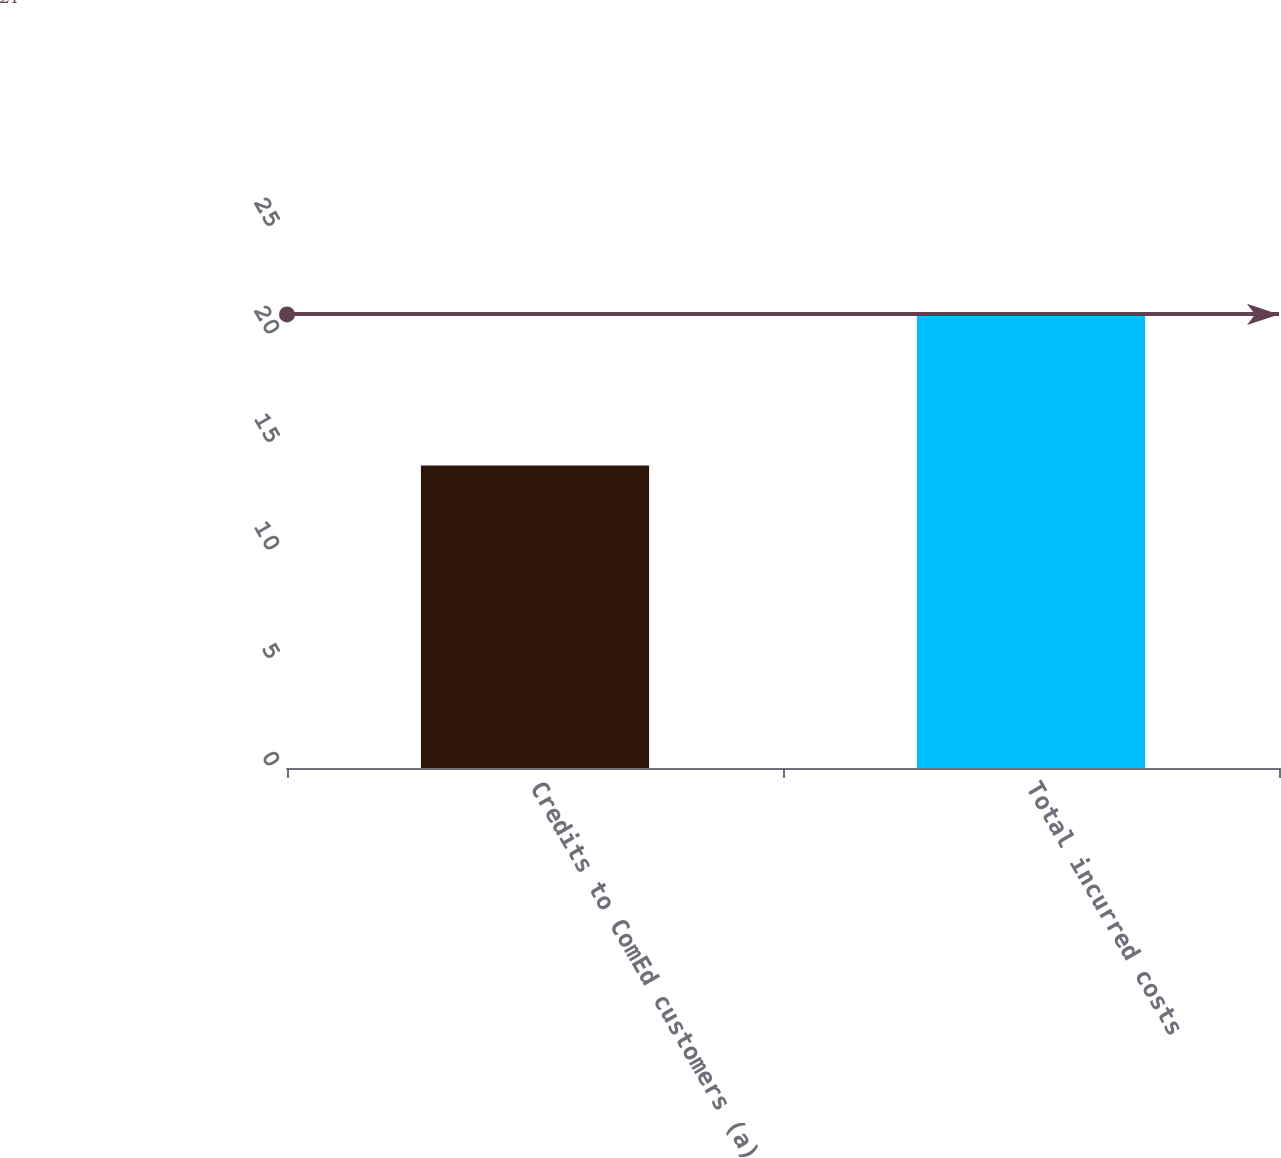Convert chart to OTSL. <chart><loc_0><loc_0><loc_500><loc_500><bar_chart><fcel>Credits to ComEd customers (a)<fcel>Total incurred costs<nl><fcel>14<fcel>21<nl></chart> 